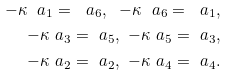Convert formula to latex. <formula><loc_0><loc_0><loc_500><loc_500>- \kappa \ a _ { 1 } = \ a _ { 6 } , \ - \kappa \ a _ { 6 } = \ a _ { 1 } , \\ - \kappa \ a _ { 3 } = \ a _ { 5 } , \ - \kappa \ a _ { 5 } = \ a _ { 3 } , \\ - \kappa \ a _ { 2 } = \ a _ { 2 } , \ - \kappa \ a _ { 4 } = \ a _ { 4 } .</formula> 